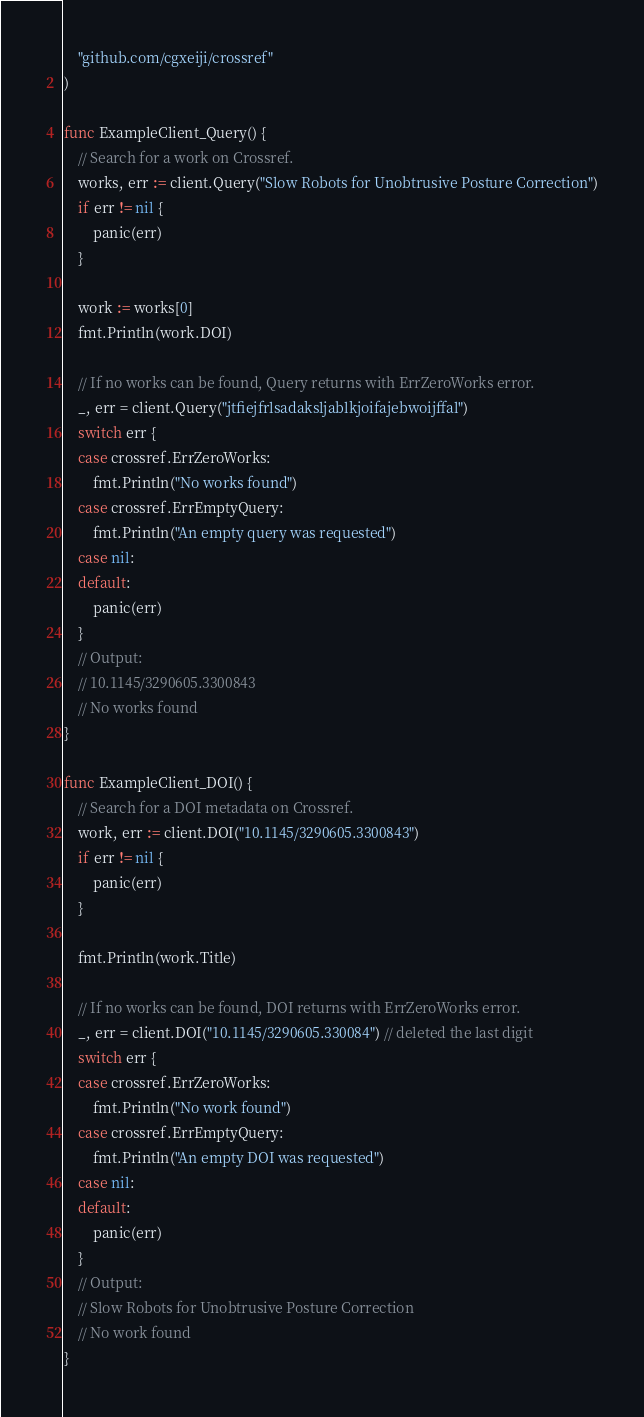<code> <loc_0><loc_0><loc_500><loc_500><_Go_>	"github.com/cgxeiji/crossref"
)

func ExampleClient_Query() {
	// Search for a work on Crossref.
	works, err := client.Query("Slow Robots for Unobtrusive Posture Correction")
	if err != nil {
		panic(err)
	}

	work := works[0]
	fmt.Println(work.DOI)

	// If no works can be found, Query returns with ErrZeroWorks error.
	_, err = client.Query("jtfiejfrlsadaksljablkjoifajebwoijffal")
	switch err {
	case crossref.ErrZeroWorks:
		fmt.Println("No works found")
	case crossref.ErrEmptyQuery:
		fmt.Println("An empty query was requested")
	case nil:
	default:
		panic(err)
	}
	// Output:
	// 10.1145/3290605.3300843
	// No works found
}

func ExampleClient_DOI() {
	// Search for a DOI metadata on Crossref.
	work, err := client.DOI("10.1145/3290605.3300843")
	if err != nil {
		panic(err)
	}

	fmt.Println(work.Title)

	// If no works can be found, DOI returns with ErrZeroWorks error.
	_, err = client.DOI("10.1145/3290605.330084") // deleted the last digit
	switch err {
	case crossref.ErrZeroWorks:
		fmt.Println("No work found")
	case crossref.ErrEmptyQuery:
		fmt.Println("An empty DOI was requested")
	case nil:
	default:
		panic(err)
	}
	// Output:
	// Slow Robots for Unobtrusive Posture Correction
	// No work found
}
</code> 